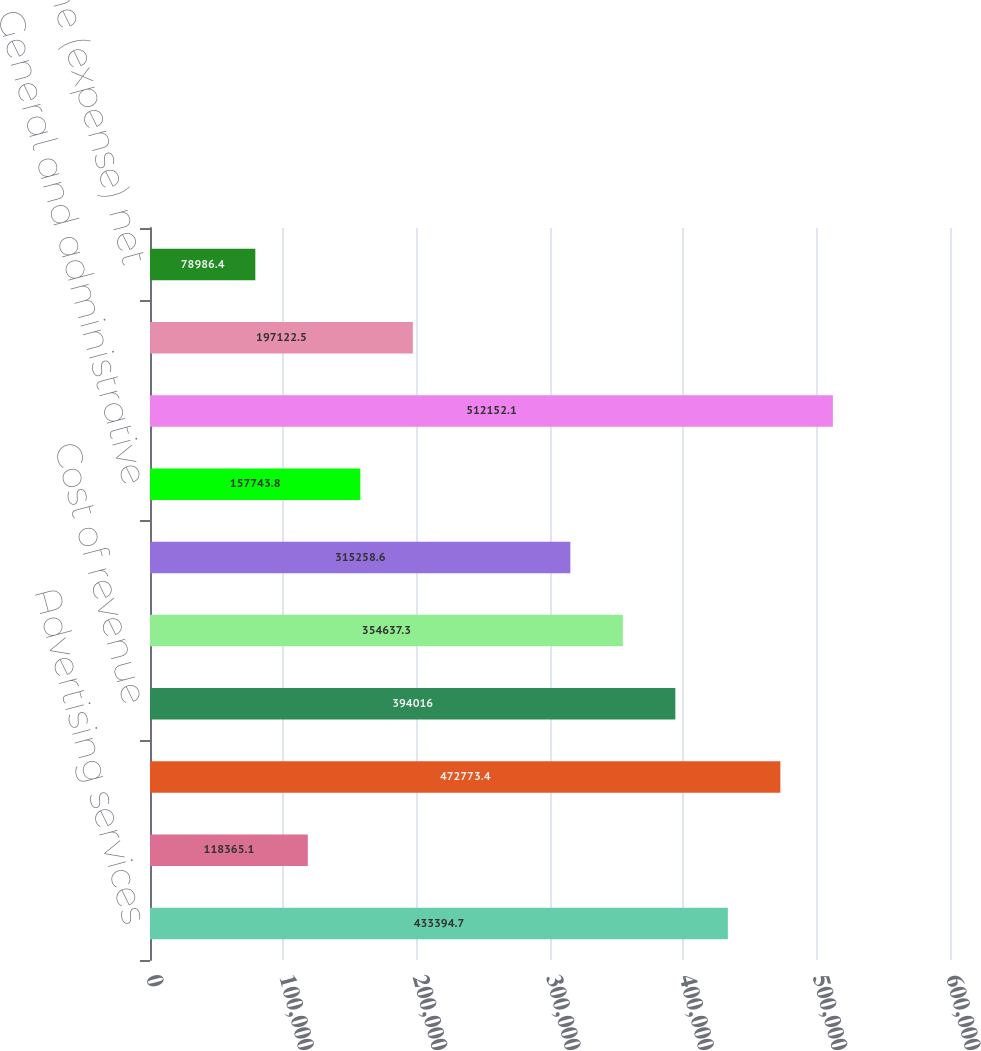Convert chart. <chart><loc_0><loc_0><loc_500><loc_500><bar_chart><fcel>Advertising services<fcel>Data licensing and other<fcel>Total Revenue<fcel>Cost of revenue<fcel>Research and development<fcel>Sales and marketing<fcel>General and administrative<fcel>Total costs and expenses<fcel>Loss from operations<fcel>Interest income (expense) net<nl><fcel>433395<fcel>118365<fcel>472773<fcel>394016<fcel>354637<fcel>315259<fcel>157744<fcel>512152<fcel>197122<fcel>78986.4<nl></chart> 